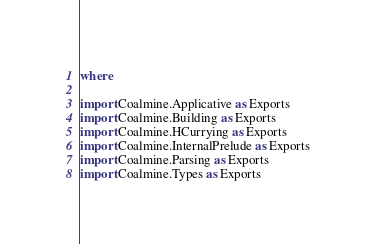<code> <loc_0><loc_0><loc_500><loc_500><_Haskell_>where

import Coalmine.Applicative as Exports
import Coalmine.Building as Exports
import Coalmine.HCurrying as Exports
import Coalmine.InternalPrelude as Exports
import Coalmine.Parsing as Exports
import Coalmine.Types as Exports
</code> 